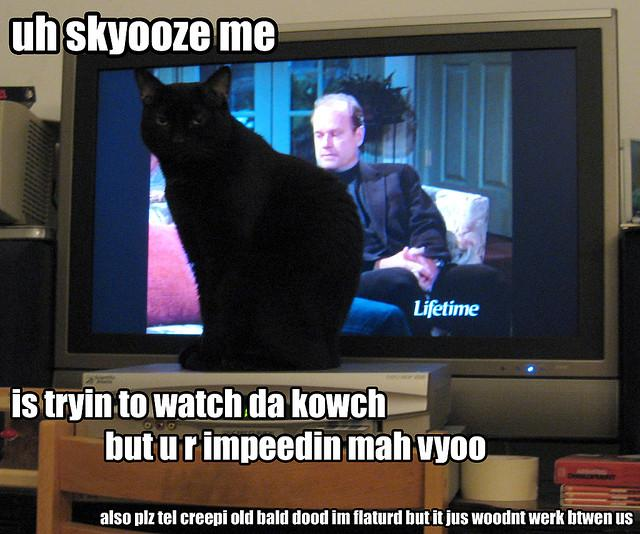What piece of furniture is misspelled here?

Choices:
A) bed
B) table
C) stool
D) couch couch 